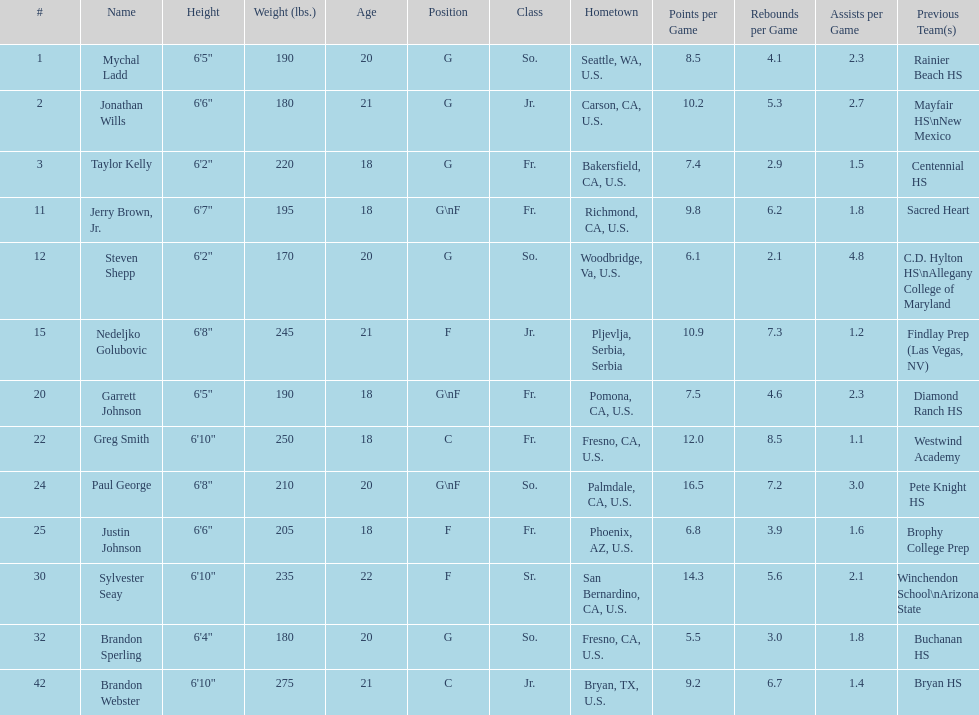Who is the next heaviest player after nedelijko golubovic? Sylvester Seay. 